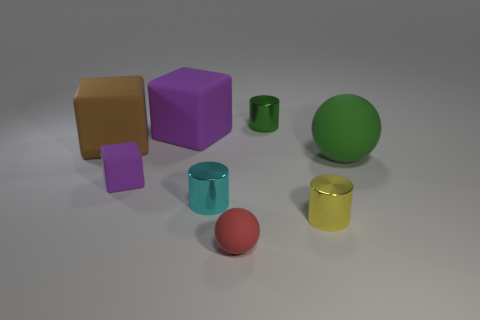What color is the matte ball behind the small purple matte thing?
Your answer should be compact. Green. How many other things are there of the same size as the brown rubber object?
Ensure brevity in your answer.  2. There is a cylinder that is behind the tiny yellow thing and in front of the big brown rubber object; what is its size?
Give a very brief answer. Small. Do the tiny block and the matte thing that is behind the brown object have the same color?
Your answer should be compact. Yes. Is there another object that has the same shape as the small red object?
Offer a very short reply. Yes. How many things are either purple blocks or tiny shiny cylinders in front of the large green rubber object?
Ensure brevity in your answer.  4. What number of other objects are the same material as the large brown cube?
Ensure brevity in your answer.  4. What number of objects are small balls or purple rubber things?
Your answer should be very brief. 3. Are there more cylinders that are on the left side of the green cylinder than tiny cubes that are in front of the red rubber ball?
Keep it short and to the point. Yes. There is a cube that is in front of the big brown matte cube; does it have the same color as the metallic cylinder that is behind the large sphere?
Keep it short and to the point. No. 